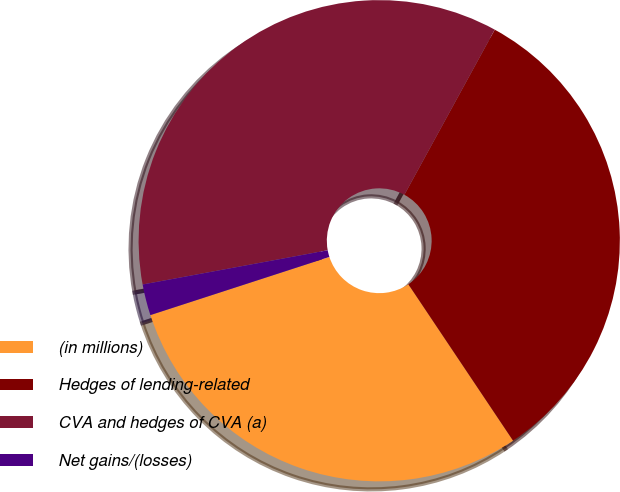<chart> <loc_0><loc_0><loc_500><loc_500><pie_chart><fcel>(in millions)<fcel>Hedges of lending-related<fcel>CVA and hedges of CVA (a)<fcel>Net gains/(losses)<nl><fcel>29.39%<fcel>32.64%<fcel>35.88%<fcel>2.09%<nl></chart> 